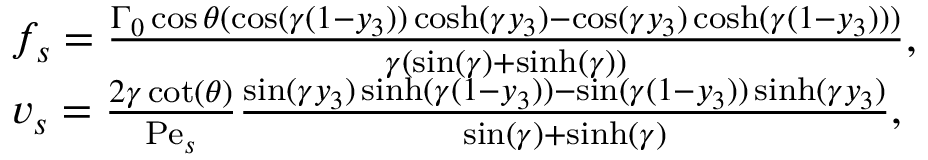Convert formula to latex. <formula><loc_0><loc_0><loc_500><loc_500>\begin{array} { r l } & { f _ { s } = \frac { \Gamma _ { 0 } \cos \theta ( \cos ( \gamma ( 1 - y _ { 3 } ) ) \cosh ( \gamma y _ { 3 } ) - \cos ( \gamma y _ { 3 } ) \cosh ( \gamma ( 1 - y _ { 3 } ) ) ) } { \gamma ( \sin ( \gamma ) + \sinh ( \gamma ) ) } , } \\ & { v _ { s } = \frac { 2 \gamma \cot ( \theta ) } { P e _ { s } } \frac { \sin ( \gamma y _ { 3 } ) \sinh ( \gamma ( 1 - y _ { 3 } ) ) - \sin ( \gamma ( 1 - y _ { 3 } ) ) \sinh ( \gamma y _ { 3 } ) } { \sin ( \gamma ) + \sinh ( \gamma ) } , } \end{array}</formula> 